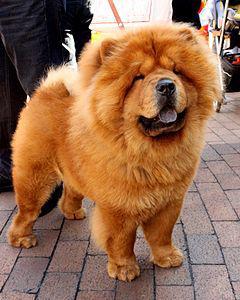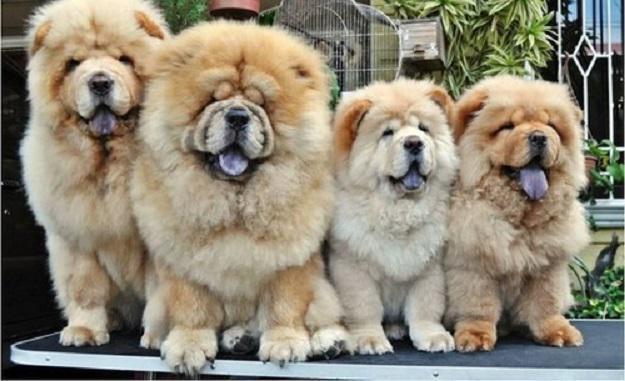The first image is the image on the left, the second image is the image on the right. Assess this claim about the two images: "An image shows one cream-colored chow in a non-standing pose on the grass.". Correct or not? Answer yes or no. No. The first image is the image on the left, the second image is the image on the right. For the images displayed, is the sentence "There are two dogs, and neither of them has anything in their mouth." factually correct? Answer yes or no. No. 